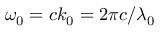<formula> <loc_0><loc_0><loc_500><loc_500>\omega _ { 0 } = c k _ { 0 } = 2 \pi c / \lambda _ { 0 }</formula> 